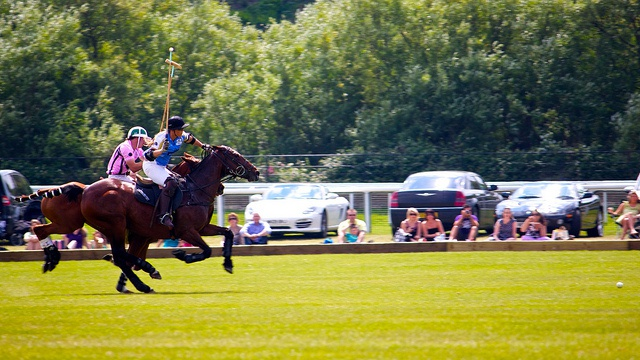Describe the objects in this image and their specific colors. I can see horse in darkgreen, black, maroon, navy, and gray tones, car in darkgreen, lavender, navy, black, and gray tones, car in darkgreen, white, darkgray, and lightblue tones, car in darkgreen, lavender, black, and gray tones, and people in darkgreen, black, lavender, gray, and navy tones in this image. 